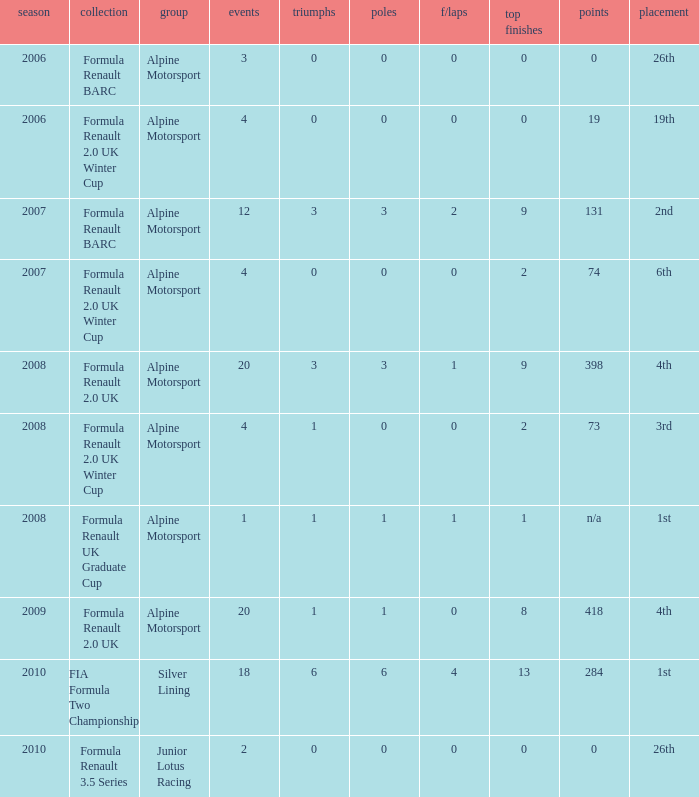What races achieved 0 f/laps and 1 pole position? 20.0. 